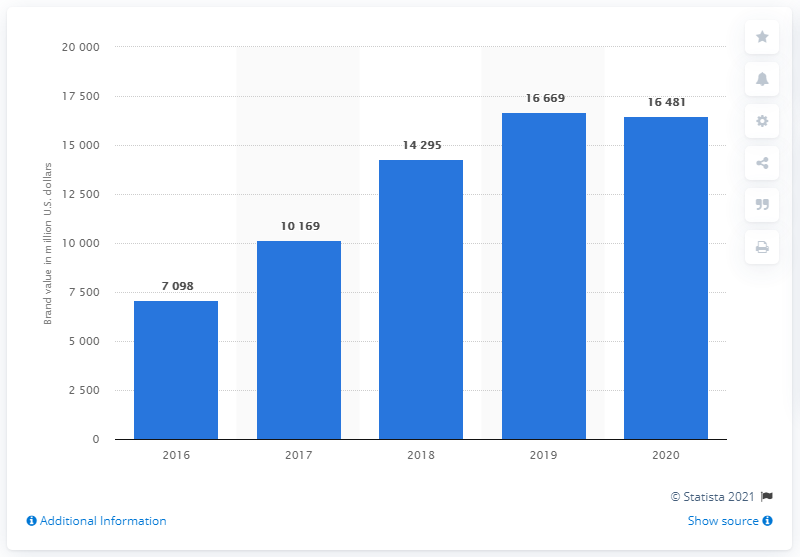Specify some key components in this picture. In 2020, Adidas was valued at approximately 16,481 U.S. dollars. 